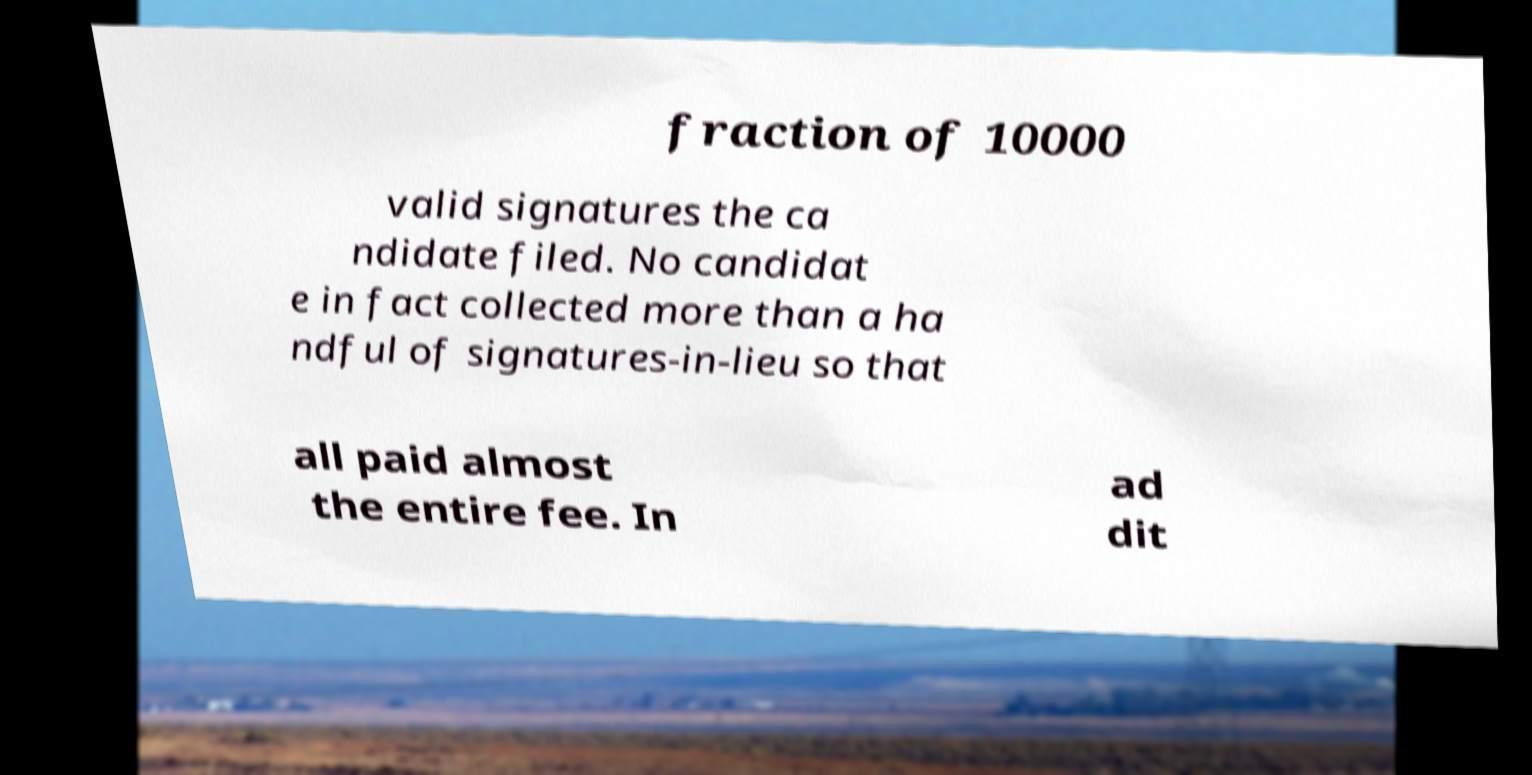What messages or text are displayed in this image? I need them in a readable, typed format. fraction of 10000 valid signatures the ca ndidate filed. No candidat e in fact collected more than a ha ndful of signatures-in-lieu so that all paid almost the entire fee. In ad dit 